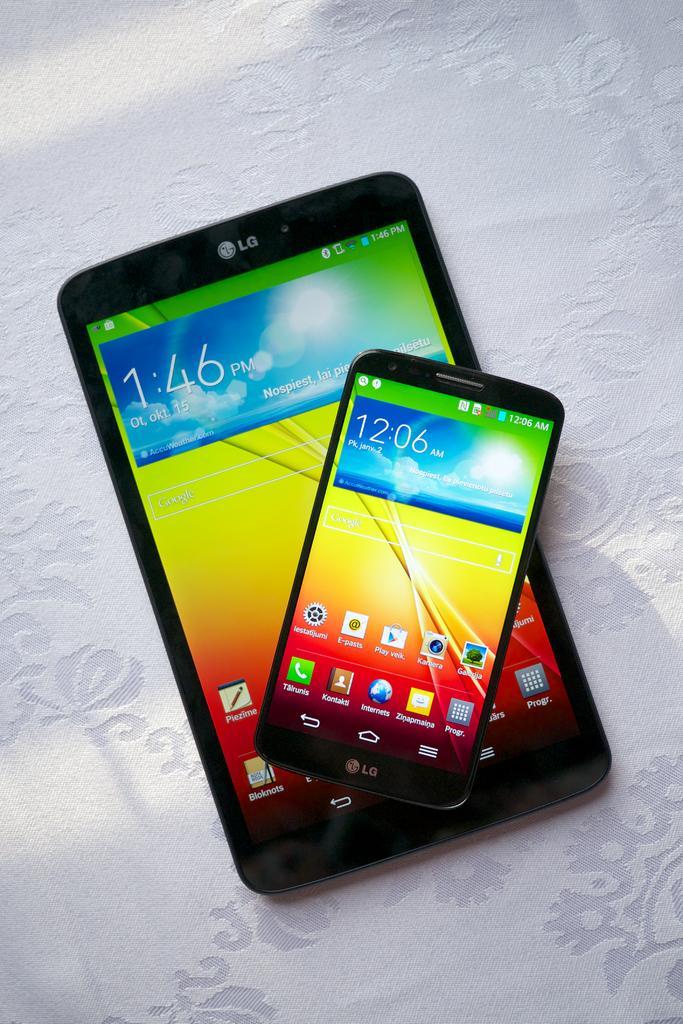Can you describe this image briefly? In this image I can see few electronic devices. They are on the white color cloth. 